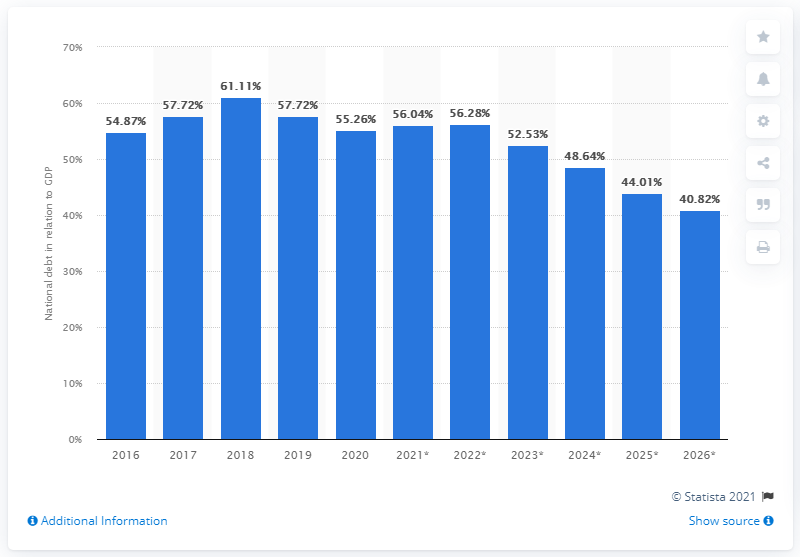List a handful of essential elements in this visual. The national debt of Ethiopia came to an end in the year 2020. In 2020, the national debt of Ethiopia accounted for 55.26% of the country's GDP. 